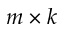<formula> <loc_0><loc_0><loc_500><loc_500>m \times k</formula> 